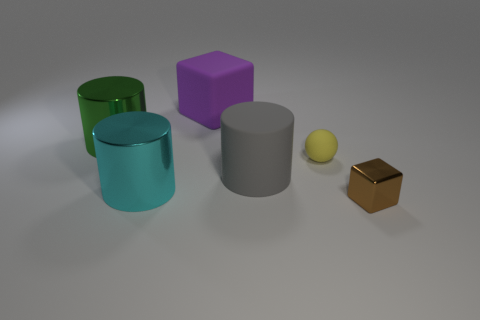What shape is the tiny matte thing?
Offer a terse response. Sphere. What number of cubes are big yellow objects or metallic things?
Ensure brevity in your answer.  1. Are there an equal number of gray cylinders behind the big rubber block and blocks that are on the left side of the big gray matte object?
Your answer should be very brief. No. What number of purple rubber things are right of the cube that is left of the cube that is in front of the large gray cylinder?
Offer a terse response. 0. Is the number of small objects behind the brown object greater than the number of small blue cubes?
Give a very brief answer. Yes. What number of objects are large things behind the yellow sphere or rubber things in front of the big cube?
Offer a very short reply. 4. There is a gray object that is the same material as the big purple cube; what size is it?
Give a very brief answer. Large. Do the large matte thing that is behind the large green cylinder and the tiny metallic thing have the same shape?
Offer a very short reply. Yes. How many green objects are either small cubes or large cylinders?
Offer a very short reply. 1. What number of other things are there of the same shape as the large gray rubber object?
Give a very brief answer. 2. 